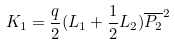Convert formula to latex. <formula><loc_0><loc_0><loc_500><loc_500>K _ { 1 } = \frac { q } { 2 } ( L _ { 1 } + \frac { 1 } { 2 } L _ { 2 } ) { \overline { P _ { 2 } } } ^ { 2 }</formula> 